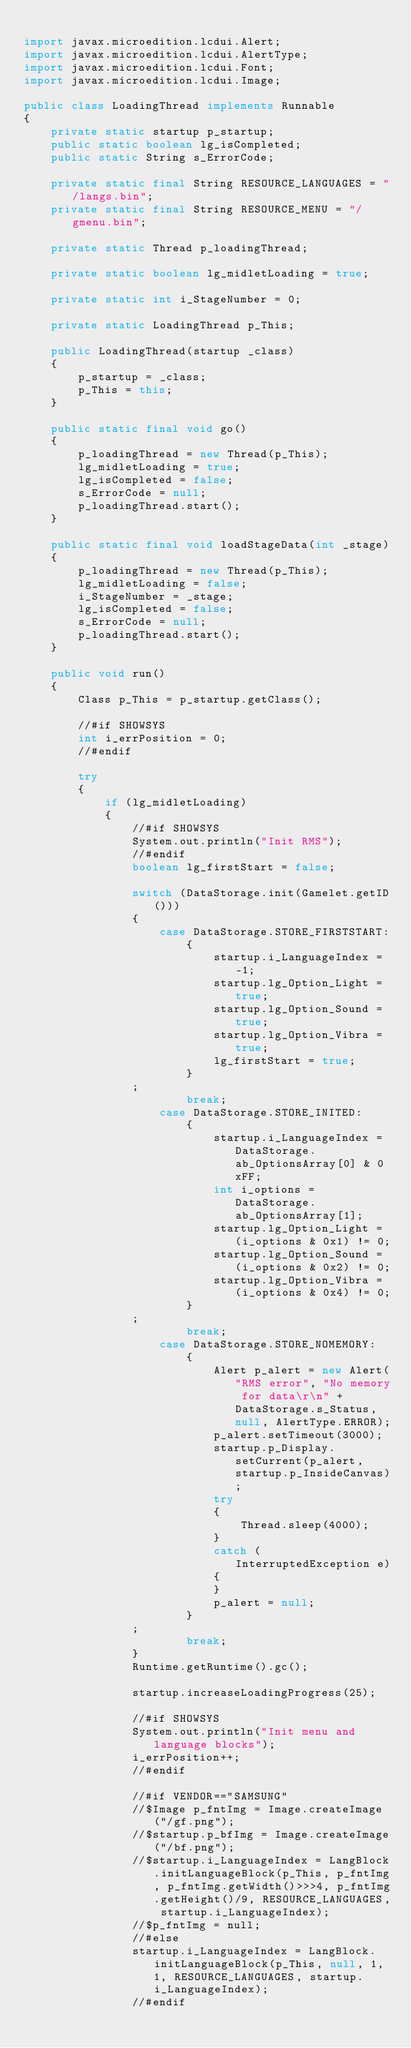Convert code to text. <code><loc_0><loc_0><loc_500><loc_500><_Java_>
import javax.microedition.lcdui.Alert;
import javax.microedition.lcdui.AlertType;
import javax.microedition.lcdui.Font;
import javax.microedition.lcdui.Image;

public class LoadingThread implements Runnable
{
    private static startup p_startup;
    public static boolean lg_isCompleted;
    public static String s_ErrorCode;

    private static final String RESOURCE_LANGUAGES = "/langs.bin";
    private static final String RESOURCE_MENU = "/gmenu.bin";

    private static Thread p_loadingThread;

    private static boolean lg_midletLoading = true;

    private static int i_StageNumber = 0;

    private static LoadingThread p_This;

    public LoadingThread(startup _class)
    {
        p_startup = _class;
        p_This = this;
    }

    public static final void go()
    {
        p_loadingThread = new Thread(p_This);
        lg_midletLoading = true;
        lg_isCompleted = false;
        s_ErrorCode = null;
        p_loadingThread.start();
    }

    public static final void loadStageData(int _stage)
    {
        p_loadingThread = new Thread(p_This);
        lg_midletLoading = false;
        i_StageNumber = _stage;
        lg_isCompleted = false;
        s_ErrorCode = null;
        p_loadingThread.start();
    }

    public void run()
    {
        Class p_This = p_startup.getClass();

        //#if SHOWSYS
        int i_errPosition = 0;
        //#endif

        try
        {
            if (lg_midletLoading)
            {
                //#if SHOWSYS
                System.out.println("Init RMS");
                //#endif
                boolean lg_firstStart = false;

                switch (DataStorage.init(Gamelet.getID()))
                {
                    case DataStorage.STORE_FIRSTSTART:
                        {
                            startup.i_LanguageIndex = -1;
                            startup.lg_Option_Light = true;
                            startup.lg_Option_Sound = true;
                            startup.lg_Option_Vibra = true;
                            lg_firstStart = true;
                        }
                ;
                        break;
                    case DataStorage.STORE_INITED:
                        {
                            startup.i_LanguageIndex = DataStorage.ab_OptionsArray[0] & 0xFF;
                            int i_options = DataStorage.ab_OptionsArray[1];
                            startup.lg_Option_Light = (i_options & 0x1) != 0;
                            startup.lg_Option_Sound = (i_options & 0x2) != 0;
                            startup.lg_Option_Vibra = (i_options & 0x4) != 0;
                        }
                ;
                        break;
                    case DataStorage.STORE_NOMEMORY:
                        {
                            Alert p_alert = new Alert("RMS error", "No memory for data\r\n" + DataStorage.s_Status, null, AlertType.ERROR);
                            p_alert.setTimeout(3000);
                            startup.p_Display.setCurrent(p_alert, startup.p_InsideCanvas);
                            try
                            {
                                Thread.sleep(4000);
                            }
                            catch (InterruptedException e)
                            {
                            }
                            p_alert = null;
                        }
                ;
                        break;
                }
                Runtime.getRuntime().gc();

                startup.increaseLoadingProgress(25);

                //#if SHOWSYS
                System.out.println("Init menu and language blocks");
                i_errPosition++;
                //#endif

                //#if VENDOR=="SAMSUNG"
                //$Image p_fntImg = Image.createImage("/gf.png");
                //$startup.p_bfImg = Image.createImage("/bf.png");
                //$startup.i_LanguageIndex = LangBlock.initLanguageBlock(p_This, p_fntImg, p_fntImg.getWidth()>>>4, p_fntImg.getHeight()/9, RESOURCE_LANGUAGES, startup.i_LanguageIndex);
                //$p_fntImg = null;
                //#else
                startup.i_LanguageIndex = LangBlock.initLanguageBlock(p_This, null, 1, 1, RESOURCE_LANGUAGES, startup.i_LanguageIndex);
                //#endif
</code> 